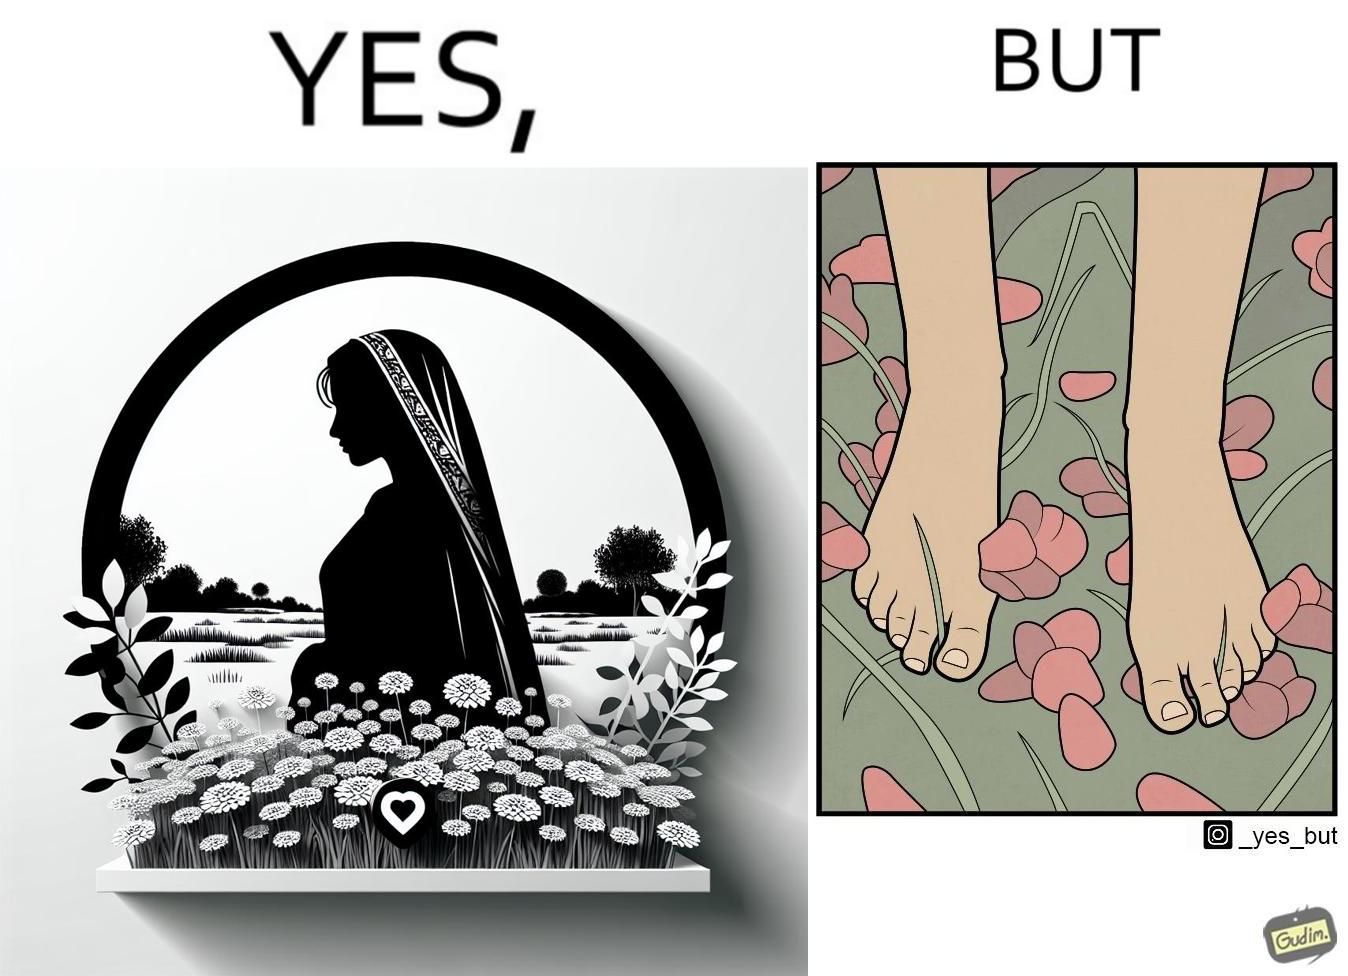Describe what you see in the left and right parts of this image. In the left part of the image: a social media post showing a woman in a field of flowers, with hashtags such as #naturelovers, #lovenature, #nature. In the right part of the image: feet stepping on flower petals surrounded by grass. 